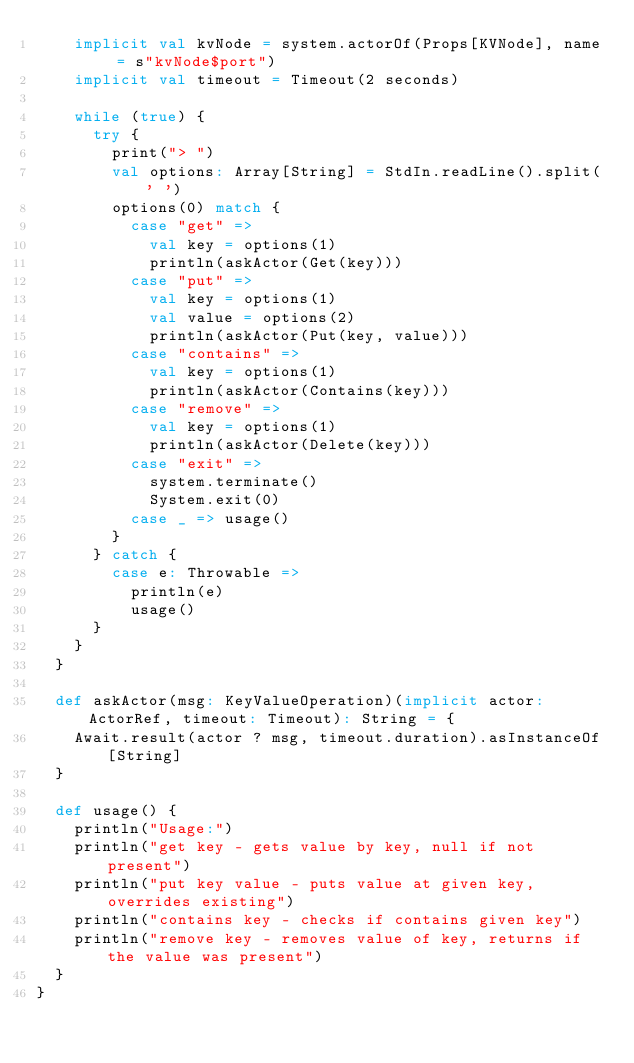<code> <loc_0><loc_0><loc_500><loc_500><_Scala_>    implicit val kvNode = system.actorOf(Props[KVNode], name = s"kvNode$port")
    implicit val timeout = Timeout(2 seconds)

    while (true) {
      try {
        print("> ")
        val options: Array[String] = StdIn.readLine().split(' ')
        options(0) match {
          case "get" =>
            val key = options(1)
            println(askActor(Get(key)))
          case "put" =>
            val key = options(1)
            val value = options(2)
            println(askActor(Put(key, value)))
          case "contains" =>
            val key = options(1)
            println(askActor(Contains(key)))
          case "remove" =>
            val key = options(1)
            println(askActor(Delete(key)))
          case "exit" =>
            system.terminate()
            System.exit(0)
          case _ => usage()
        }
      } catch {
        case e: Throwable =>
          println(e)
          usage()
      }
    }
  }

  def askActor(msg: KeyValueOperation)(implicit actor: ActorRef, timeout: Timeout): String = {
    Await.result(actor ? msg, timeout.duration).asInstanceOf[String]
  }

  def usage() {
    println("Usage:")
    println("get key - gets value by key, null if not present")
    println("put key value - puts value at given key, overrides existing")
    println("contains key - checks if contains given key")
    println("remove key - removes value of key, returns if the value was present")
  }
}
</code> 